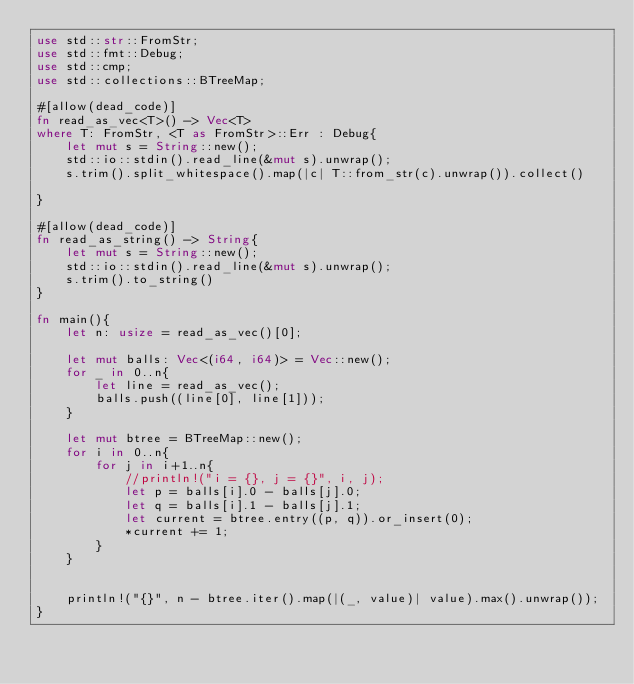<code> <loc_0><loc_0><loc_500><loc_500><_Rust_>use std::str::FromStr;
use std::fmt::Debug;
use std::cmp;
use std::collections::BTreeMap;

#[allow(dead_code)]
fn read_as_vec<T>() -> Vec<T>
where T: FromStr, <T as FromStr>::Err : Debug{
    let mut s = String::new();
    std::io::stdin().read_line(&mut s).unwrap();
    s.trim().split_whitespace().map(|c| T::from_str(c).unwrap()).collect()

}

#[allow(dead_code)]
fn read_as_string() -> String{
    let mut s = String::new();
    std::io::stdin().read_line(&mut s).unwrap();
    s.trim().to_string()
}

fn main(){
    let n: usize = read_as_vec()[0];

    let mut balls: Vec<(i64, i64)> = Vec::new();
    for _ in 0..n{
        let line = read_as_vec();
        balls.push((line[0], line[1]));
    }

    let mut btree = BTreeMap::new();
    for i in 0..n{
        for j in i+1..n{
            //println!("i = {}, j = {}", i, j);
            let p = balls[i].0 - balls[j].0;
            let q = balls[i].1 - balls[j].1;
            let current = btree.entry((p, q)).or_insert(0);
            *current += 1;
        }
    }


    println!("{}", n - btree.iter().map(|(_, value)| value).max().unwrap());    
}
</code> 